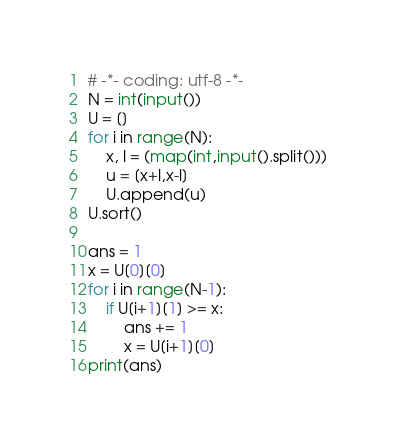<code> <loc_0><loc_0><loc_500><loc_500><_Python_># -*- coding: utf-8 -*-
N = int(input())
U = []
for i in range(N):    
    x, l = (map(int,input().split()))
    u = [x+l,x-l]
    U.append(u)
U.sort()

ans = 1
x = U[0][0]
for i in range(N-1):
    if U[i+1][1] >= x:
        ans += 1
        x = U[i+1][0]
print(ans)</code> 